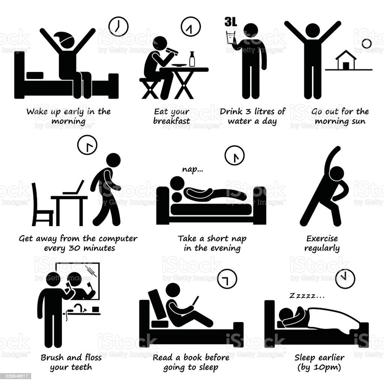Could enhancing one's morning routine with sunlight exposure, as shown in the image, have benefits beyond just health? Absolutely, the morning sun exposure depicted in the image offers several benefits beyond physical health. It can enhance mood, increase Vitamin D levels, and improve mental health, potentially reducing the risk of mood disorders and setting a positive tone for the entire day. 